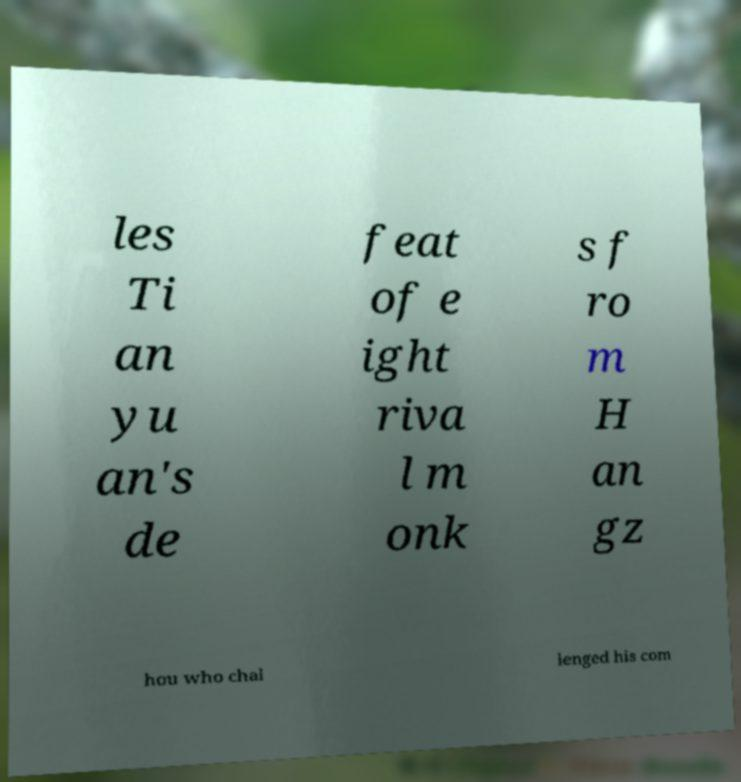What messages or text are displayed in this image? I need them in a readable, typed format. les Ti an yu an's de feat of e ight riva l m onk s f ro m H an gz hou who chal lenged his com 